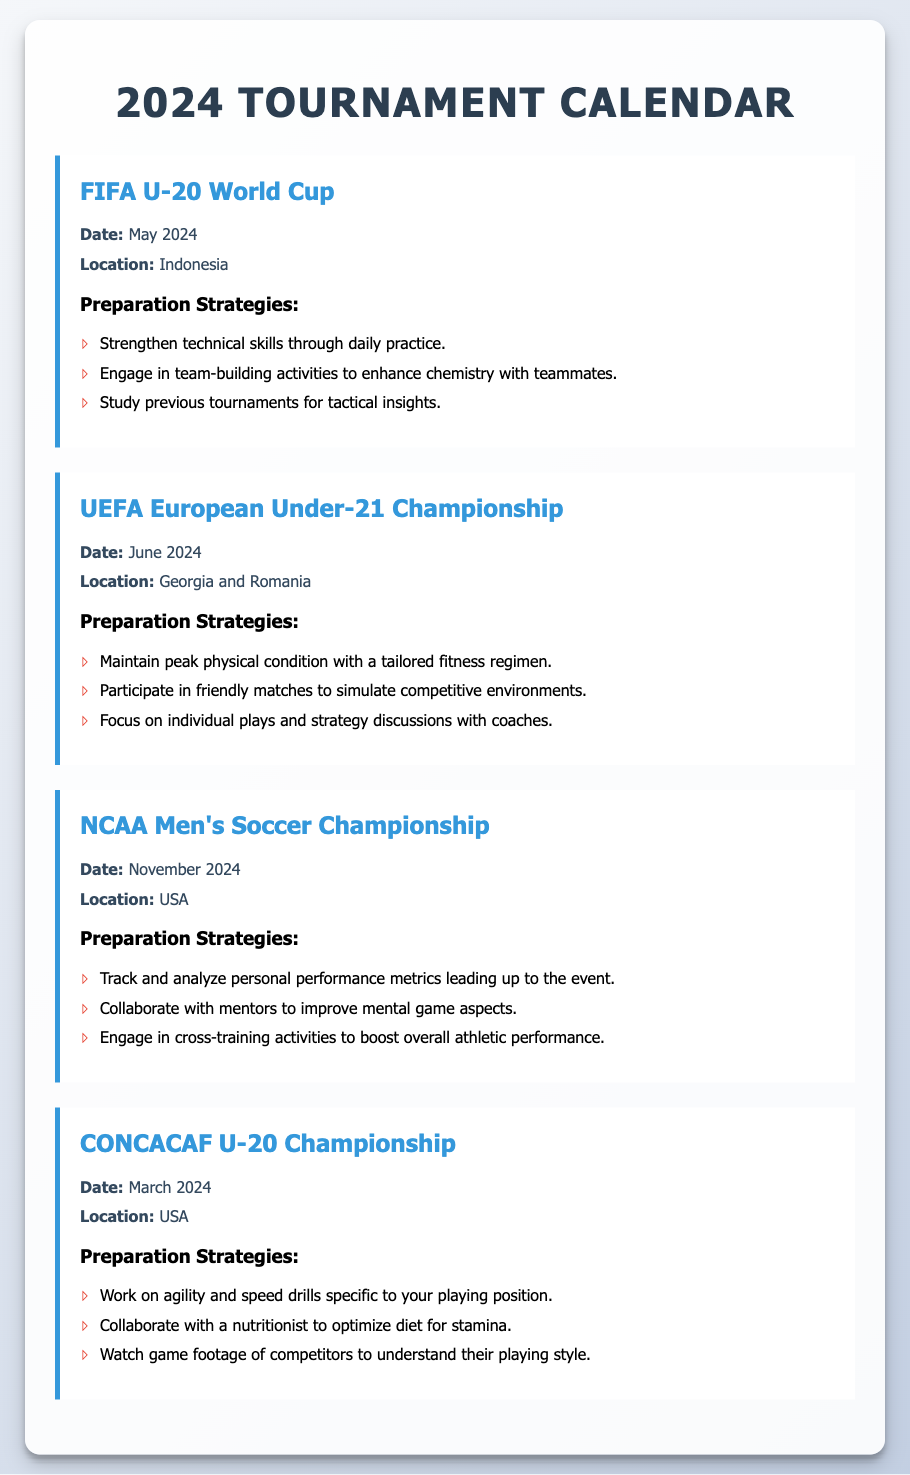What is the date of the FIFA U-20 World Cup? The date is mentioned as May 2024 in the document.
Answer: May 2024 Where is the UEFA European Under-21 Championship taking place? The locations are specified as Georgia and Romania in the document.
Answer: Georgia and Romania What are the preparation strategies for the NCAA Men's Soccer Championship? The strategies are listed in the tournament section, including performance metrics tracking and collaboration with mentors.
Answer: Track and analyze personal performance metrics, collaborate with mentors, engage in cross-training activities When is the CONCACAF U-20 Championship scheduled? The date is explicitly stated as March 2024 in the document.
Answer: March 2024 What is one of the preparation strategies for the FIFA U-20 World Cup? The strategies include strengthening technical skills through daily practice, which is mentioned in the document.
Answer: Strengthen technical skills through daily practice How many tournaments are listed in the document? The document details four tournaments, which can be counted from the sections provided.
Answer: Four What is a key focus for preparation in the UEFA European Under-21 Championship? The document mentions maintaining peak physical condition as a key focus for the championship.
Answer: Maintain peak physical condition What is the location for the NCAA Men's Soccer Championship? The location is stated as the USA in the document.
Answer: USA 